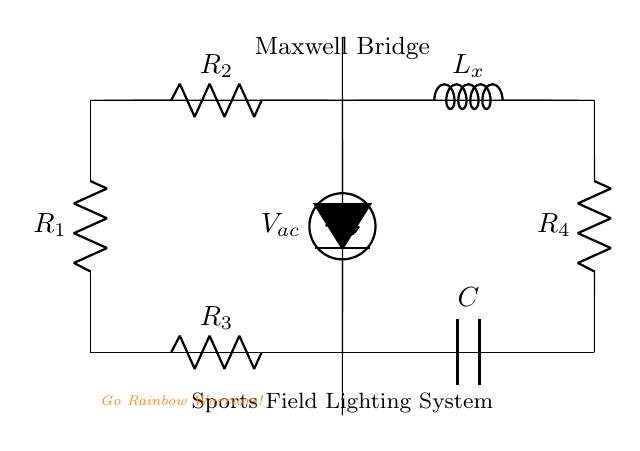What is the purpose of this circuit? The purpose of the Maxwell bridge circuit is to measure inductance, which is essential for determining the characteristics of inductive components in sports field lighting systems.
Answer: Measure inductance How many resistors are in the circuit? The circuit includes three resistors labeled R1, R2, and R3, along with one additional resistor R4.
Answer: Four resistors What component is represented by L_x? The component L_x represents the inductor whose inductance is being measured in the Maxwell bridge configuration.
Answer: Inductor What type of voltage source is used in this circuit? The circuit uses an AC sinusoidal voltage source which is indicated by the symbol present in the diagram, essential for bridge operation.
Answer: Sinusoidal voltage source Why is a capacitor included in the circuit? The capacitor is included in the Maxwell bridge setup to balance the circuit for accurate inductance measurement by compensating for the reactance introduced by the inductor.
Answer: To balance the circuit What does the detector measure in this circuit? The detector is used to measure the null voltage condition across the bridge when the circuit is balanced, indicating that the inductance of L_x is equal to the calculated inductance from resistors and capacitors.
Answer: Null voltage 